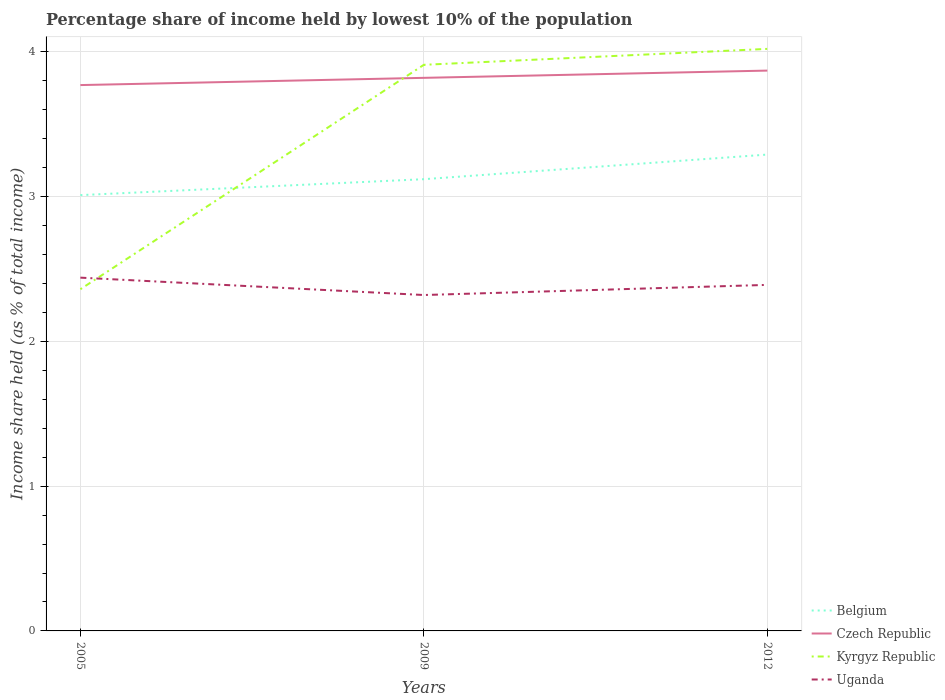How many different coloured lines are there?
Offer a terse response. 4. Does the line corresponding to Uganda intersect with the line corresponding to Czech Republic?
Ensure brevity in your answer.  No. Across all years, what is the maximum percentage share of income held by lowest 10% of the population in Belgium?
Ensure brevity in your answer.  3.01. In which year was the percentage share of income held by lowest 10% of the population in Czech Republic maximum?
Keep it short and to the point. 2005. What is the total percentage share of income held by lowest 10% of the population in Czech Republic in the graph?
Provide a succinct answer. -0.05. What is the difference between the highest and the second highest percentage share of income held by lowest 10% of the population in Czech Republic?
Make the answer very short. 0.1. What is the difference between the highest and the lowest percentage share of income held by lowest 10% of the population in Uganda?
Offer a terse response. 2. How many lines are there?
Your answer should be very brief. 4. How many years are there in the graph?
Give a very brief answer. 3. Are the values on the major ticks of Y-axis written in scientific E-notation?
Your answer should be very brief. No. Does the graph contain any zero values?
Your answer should be compact. No. Does the graph contain grids?
Give a very brief answer. Yes. Where does the legend appear in the graph?
Your answer should be very brief. Bottom right. What is the title of the graph?
Provide a short and direct response. Percentage share of income held by lowest 10% of the population. Does "Ukraine" appear as one of the legend labels in the graph?
Your answer should be compact. No. What is the label or title of the Y-axis?
Ensure brevity in your answer.  Income share held (as % of total income). What is the Income share held (as % of total income) in Belgium in 2005?
Offer a very short reply. 3.01. What is the Income share held (as % of total income) in Czech Republic in 2005?
Ensure brevity in your answer.  3.77. What is the Income share held (as % of total income) of Kyrgyz Republic in 2005?
Offer a terse response. 2.36. What is the Income share held (as % of total income) of Uganda in 2005?
Offer a terse response. 2.44. What is the Income share held (as % of total income) of Belgium in 2009?
Keep it short and to the point. 3.12. What is the Income share held (as % of total income) of Czech Republic in 2009?
Make the answer very short. 3.82. What is the Income share held (as % of total income) in Kyrgyz Republic in 2009?
Offer a terse response. 3.91. What is the Income share held (as % of total income) in Uganda in 2009?
Provide a succinct answer. 2.32. What is the Income share held (as % of total income) of Belgium in 2012?
Ensure brevity in your answer.  3.29. What is the Income share held (as % of total income) in Czech Republic in 2012?
Offer a very short reply. 3.87. What is the Income share held (as % of total income) of Kyrgyz Republic in 2012?
Keep it short and to the point. 4.02. What is the Income share held (as % of total income) in Uganda in 2012?
Your response must be concise. 2.39. Across all years, what is the maximum Income share held (as % of total income) in Belgium?
Your response must be concise. 3.29. Across all years, what is the maximum Income share held (as % of total income) in Czech Republic?
Offer a terse response. 3.87. Across all years, what is the maximum Income share held (as % of total income) in Kyrgyz Republic?
Keep it short and to the point. 4.02. Across all years, what is the maximum Income share held (as % of total income) in Uganda?
Ensure brevity in your answer.  2.44. Across all years, what is the minimum Income share held (as % of total income) in Belgium?
Keep it short and to the point. 3.01. Across all years, what is the minimum Income share held (as % of total income) in Czech Republic?
Your response must be concise. 3.77. Across all years, what is the minimum Income share held (as % of total income) of Kyrgyz Republic?
Provide a short and direct response. 2.36. Across all years, what is the minimum Income share held (as % of total income) in Uganda?
Your answer should be compact. 2.32. What is the total Income share held (as % of total income) in Belgium in the graph?
Offer a terse response. 9.42. What is the total Income share held (as % of total income) in Czech Republic in the graph?
Keep it short and to the point. 11.46. What is the total Income share held (as % of total income) of Kyrgyz Republic in the graph?
Provide a succinct answer. 10.29. What is the total Income share held (as % of total income) in Uganda in the graph?
Your answer should be very brief. 7.15. What is the difference between the Income share held (as % of total income) in Belgium in 2005 and that in 2009?
Offer a very short reply. -0.11. What is the difference between the Income share held (as % of total income) in Kyrgyz Republic in 2005 and that in 2009?
Keep it short and to the point. -1.55. What is the difference between the Income share held (as % of total income) of Uganda in 2005 and that in 2009?
Provide a short and direct response. 0.12. What is the difference between the Income share held (as % of total income) in Belgium in 2005 and that in 2012?
Keep it short and to the point. -0.28. What is the difference between the Income share held (as % of total income) of Kyrgyz Republic in 2005 and that in 2012?
Provide a succinct answer. -1.66. What is the difference between the Income share held (as % of total income) of Uganda in 2005 and that in 2012?
Your answer should be compact. 0.05. What is the difference between the Income share held (as % of total income) in Belgium in 2009 and that in 2012?
Provide a short and direct response. -0.17. What is the difference between the Income share held (as % of total income) of Kyrgyz Republic in 2009 and that in 2012?
Your answer should be very brief. -0.11. What is the difference between the Income share held (as % of total income) in Uganda in 2009 and that in 2012?
Offer a very short reply. -0.07. What is the difference between the Income share held (as % of total income) of Belgium in 2005 and the Income share held (as % of total income) of Czech Republic in 2009?
Offer a very short reply. -0.81. What is the difference between the Income share held (as % of total income) in Belgium in 2005 and the Income share held (as % of total income) in Uganda in 2009?
Ensure brevity in your answer.  0.69. What is the difference between the Income share held (as % of total income) in Czech Republic in 2005 and the Income share held (as % of total income) in Kyrgyz Republic in 2009?
Your answer should be very brief. -0.14. What is the difference between the Income share held (as % of total income) of Czech Republic in 2005 and the Income share held (as % of total income) of Uganda in 2009?
Keep it short and to the point. 1.45. What is the difference between the Income share held (as % of total income) of Kyrgyz Republic in 2005 and the Income share held (as % of total income) of Uganda in 2009?
Your answer should be very brief. 0.04. What is the difference between the Income share held (as % of total income) in Belgium in 2005 and the Income share held (as % of total income) in Czech Republic in 2012?
Offer a terse response. -0.86. What is the difference between the Income share held (as % of total income) in Belgium in 2005 and the Income share held (as % of total income) in Kyrgyz Republic in 2012?
Offer a terse response. -1.01. What is the difference between the Income share held (as % of total income) in Belgium in 2005 and the Income share held (as % of total income) in Uganda in 2012?
Provide a short and direct response. 0.62. What is the difference between the Income share held (as % of total income) in Czech Republic in 2005 and the Income share held (as % of total income) in Uganda in 2012?
Make the answer very short. 1.38. What is the difference between the Income share held (as % of total income) of Kyrgyz Republic in 2005 and the Income share held (as % of total income) of Uganda in 2012?
Provide a succinct answer. -0.03. What is the difference between the Income share held (as % of total income) of Belgium in 2009 and the Income share held (as % of total income) of Czech Republic in 2012?
Provide a short and direct response. -0.75. What is the difference between the Income share held (as % of total income) of Belgium in 2009 and the Income share held (as % of total income) of Uganda in 2012?
Keep it short and to the point. 0.73. What is the difference between the Income share held (as % of total income) of Czech Republic in 2009 and the Income share held (as % of total income) of Kyrgyz Republic in 2012?
Keep it short and to the point. -0.2. What is the difference between the Income share held (as % of total income) of Czech Republic in 2009 and the Income share held (as % of total income) of Uganda in 2012?
Give a very brief answer. 1.43. What is the difference between the Income share held (as % of total income) of Kyrgyz Republic in 2009 and the Income share held (as % of total income) of Uganda in 2012?
Keep it short and to the point. 1.52. What is the average Income share held (as % of total income) in Belgium per year?
Offer a very short reply. 3.14. What is the average Income share held (as % of total income) in Czech Republic per year?
Provide a short and direct response. 3.82. What is the average Income share held (as % of total income) in Kyrgyz Republic per year?
Give a very brief answer. 3.43. What is the average Income share held (as % of total income) of Uganda per year?
Your answer should be very brief. 2.38. In the year 2005, what is the difference between the Income share held (as % of total income) of Belgium and Income share held (as % of total income) of Czech Republic?
Your answer should be very brief. -0.76. In the year 2005, what is the difference between the Income share held (as % of total income) of Belgium and Income share held (as % of total income) of Kyrgyz Republic?
Provide a succinct answer. 0.65. In the year 2005, what is the difference between the Income share held (as % of total income) in Belgium and Income share held (as % of total income) in Uganda?
Your answer should be compact. 0.57. In the year 2005, what is the difference between the Income share held (as % of total income) of Czech Republic and Income share held (as % of total income) of Kyrgyz Republic?
Your response must be concise. 1.41. In the year 2005, what is the difference between the Income share held (as % of total income) of Czech Republic and Income share held (as % of total income) of Uganda?
Give a very brief answer. 1.33. In the year 2005, what is the difference between the Income share held (as % of total income) of Kyrgyz Republic and Income share held (as % of total income) of Uganda?
Your answer should be compact. -0.08. In the year 2009, what is the difference between the Income share held (as % of total income) of Belgium and Income share held (as % of total income) of Kyrgyz Republic?
Offer a terse response. -0.79. In the year 2009, what is the difference between the Income share held (as % of total income) of Belgium and Income share held (as % of total income) of Uganda?
Provide a short and direct response. 0.8. In the year 2009, what is the difference between the Income share held (as % of total income) in Czech Republic and Income share held (as % of total income) in Kyrgyz Republic?
Make the answer very short. -0.09. In the year 2009, what is the difference between the Income share held (as % of total income) of Kyrgyz Republic and Income share held (as % of total income) of Uganda?
Your answer should be compact. 1.59. In the year 2012, what is the difference between the Income share held (as % of total income) in Belgium and Income share held (as % of total income) in Czech Republic?
Keep it short and to the point. -0.58. In the year 2012, what is the difference between the Income share held (as % of total income) in Belgium and Income share held (as % of total income) in Kyrgyz Republic?
Offer a terse response. -0.73. In the year 2012, what is the difference between the Income share held (as % of total income) in Czech Republic and Income share held (as % of total income) in Uganda?
Provide a short and direct response. 1.48. In the year 2012, what is the difference between the Income share held (as % of total income) of Kyrgyz Republic and Income share held (as % of total income) of Uganda?
Your answer should be compact. 1.63. What is the ratio of the Income share held (as % of total income) in Belgium in 2005 to that in 2009?
Offer a terse response. 0.96. What is the ratio of the Income share held (as % of total income) of Czech Republic in 2005 to that in 2009?
Offer a terse response. 0.99. What is the ratio of the Income share held (as % of total income) in Kyrgyz Republic in 2005 to that in 2009?
Your response must be concise. 0.6. What is the ratio of the Income share held (as % of total income) in Uganda in 2005 to that in 2009?
Provide a short and direct response. 1.05. What is the ratio of the Income share held (as % of total income) in Belgium in 2005 to that in 2012?
Make the answer very short. 0.91. What is the ratio of the Income share held (as % of total income) in Czech Republic in 2005 to that in 2012?
Provide a short and direct response. 0.97. What is the ratio of the Income share held (as % of total income) in Kyrgyz Republic in 2005 to that in 2012?
Your response must be concise. 0.59. What is the ratio of the Income share held (as % of total income) in Uganda in 2005 to that in 2012?
Ensure brevity in your answer.  1.02. What is the ratio of the Income share held (as % of total income) of Belgium in 2009 to that in 2012?
Your answer should be compact. 0.95. What is the ratio of the Income share held (as % of total income) of Czech Republic in 2009 to that in 2012?
Your response must be concise. 0.99. What is the ratio of the Income share held (as % of total income) in Kyrgyz Republic in 2009 to that in 2012?
Your response must be concise. 0.97. What is the ratio of the Income share held (as % of total income) of Uganda in 2009 to that in 2012?
Give a very brief answer. 0.97. What is the difference between the highest and the second highest Income share held (as % of total income) in Belgium?
Your answer should be compact. 0.17. What is the difference between the highest and the second highest Income share held (as % of total income) in Kyrgyz Republic?
Ensure brevity in your answer.  0.11. What is the difference between the highest and the lowest Income share held (as % of total income) of Belgium?
Provide a short and direct response. 0.28. What is the difference between the highest and the lowest Income share held (as % of total income) in Kyrgyz Republic?
Offer a terse response. 1.66. What is the difference between the highest and the lowest Income share held (as % of total income) of Uganda?
Make the answer very short. 0.12. 